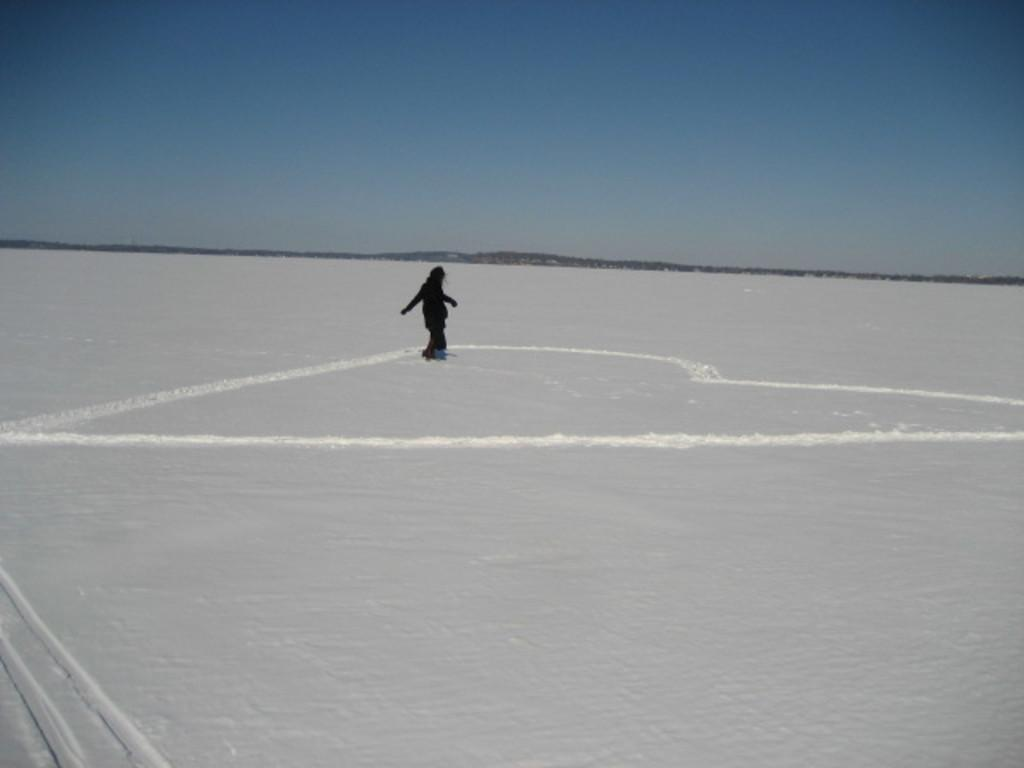What is the main subject of the image? There is a person in the image. What is the person doing in the image? The person is skating. What is the condition of the ground in the image? The ground is snowy. Where is the skating taking place in the image? The skating is taking place in the middle of the image. What is visible at the top of the image? The sky is visible at the top of the image. What type of jewel is the maid wearing in the image? There is no maid or jewel present in the image; it features a person skating on a snowy ground. 